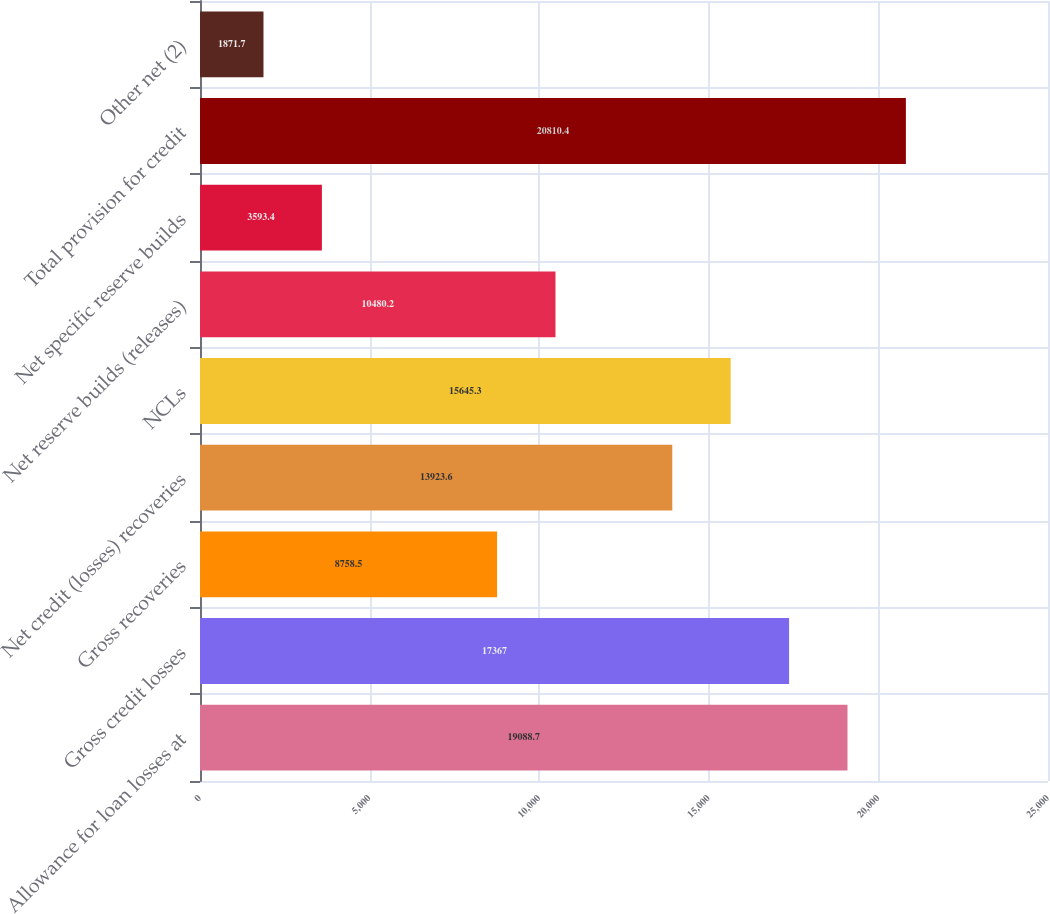<chart> <loc_0><loc_0><loc_500><loc_500><bar_chart><fcel>Allowance for loan losses at<fcel>Gross credit losses<fcel>Gross recoveries<fcel>Net credit (losses) recoveries<fcel>NCLs<fcel>Net reserve builds (releases)<fcel>Net specific reserve builds<fcel>Total provision for credit<fcel>Other net (2)<nl><fcel>19088.7<fcel>17367<fcel>8758.5<fcel>13923.6<fcel>15645.3<fcel>10480.2<fcel>3593.4<fcel>20810.4<fcel>1871.7<nl></chart> 